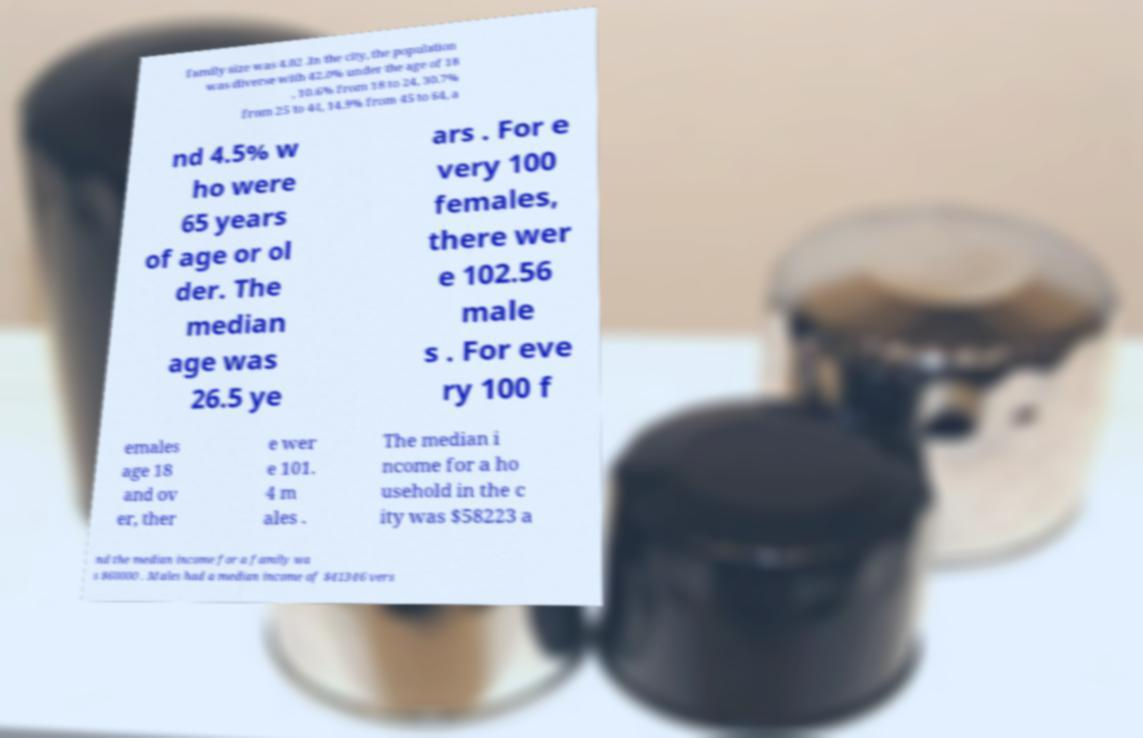Could you extract and type out the text from this image? family size was 4.02 .In the city, the population was diverse with 42.0% under the age of 18 , 10.6% from 18 to 24, 30.7% from 25 to 44, 14.9% from 45 to 64, a nd 4.5% w ho were 65 years of age or ol der. The median age was 26.5 ye ars . For e very 100 females, there wer e 102.56 male s . For eve ry 100 f emales age 18 and ov er, ther e wer e 101. 4 m ales . The median i ncome for a ho usehold in the c ity was $58223 a nd the median income for a family wa s $60000 . Males had a median income of $41346 vers 